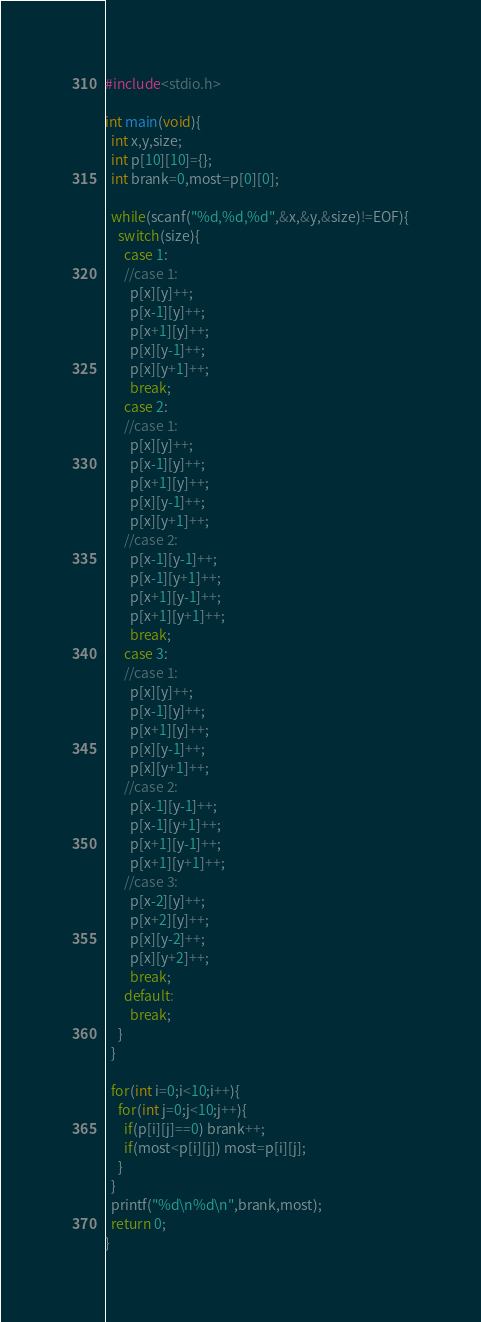<code> <loc_0><loc_0><loc_500><loc_500><_C_>#include<stdio.h>

int main(void){
  int x,y,size;
  int p[10][10]={};
  int brank=0,most=p[0][0];

  while(scanf("%d,%d,%d",&x,&y,&size)!=EOF){
    switch(size){
      case 1:
      //case 1:
        p[x][y]++;
        p[x-1][y]++;
        p[x+1][y]++;
        p[x][y-1]++;
        p[x][y+1]++;
        break;
      case 2:
      //case 1:
        p[x][y]++;
        p[x-1][y]++;
        p[x+1][y]++;
        p[x][y-1]++;
        p[x][y+1]++;
      //case 2:
        p[x-1][y-1]++;
        p[x-1][y+1]++;
        p[x+1][y-1]++;
        p[x+1][y+1]++;
        break;
      case 3:
      //case 1:
        p[x][y]++;
        p[x-1][y]++;
        p[x+1][y]++;
        p[x][y-1]++;
        p[x][y+1]++;
      //case 2:
        p[x-1][y-1]++;
        p[x-1][y+1]++;
        p[x+1][y-1]++;
        p[x+1][y+1]++;
      //case 3:
        p[x-2][y]++;
        p[x+2][y]++;
        p[x][y-2]++;
        p[x][y+2]++;
        break;
      default:
        break;
    }
  }

  for(int i=0;i<10;i++){
    for(int j=0;j<10;j++){
      if(p[i][j]==0) brank++;
      if(most<p[i][j]) most=p[i][j];
    }
  }
  printf("%d\n%d\n",brank,most);
  return 0;
}

</code> 